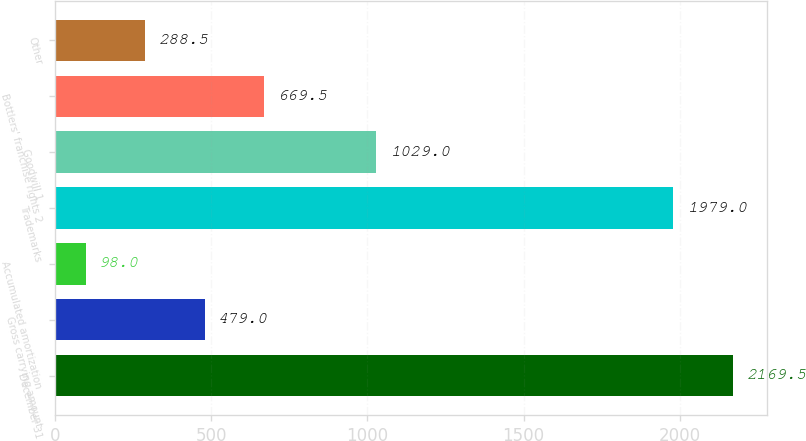<chart> <loc_0><loc_0><loc_500><loc_500><bar_chart><fcel>December 31<fcel>Gross carrying amount<fcel>Accumulated amortization<fcel>Trademarks<fcel>Goodwill 1<fcel>Bottlers' franchise rights 2<fcel>Other<nl><fcel>2169.5<fcel>479<fcel>98<fcel>1979<fcel>1029<fcel>669.5<fcel>288.5<nl></chart> 